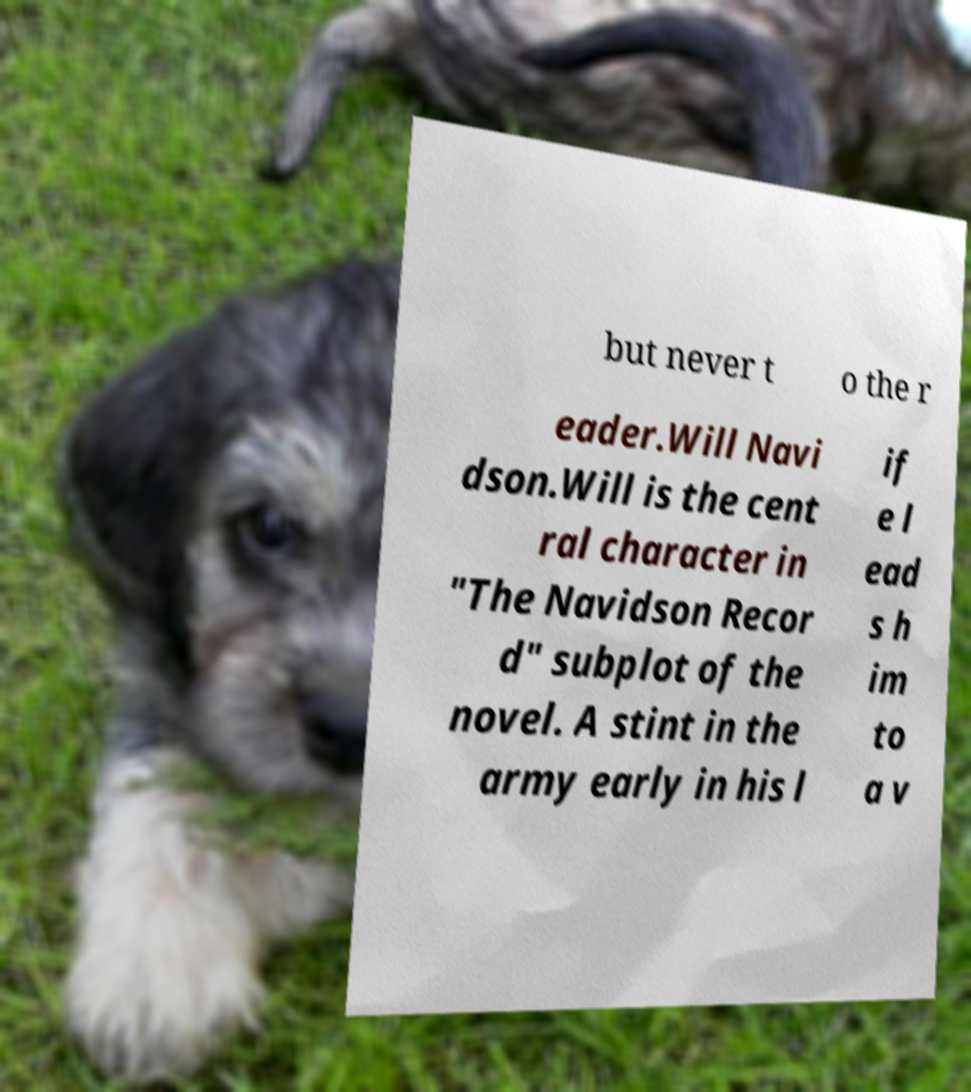What messages or text are displayed in this image? I need them in a readable, typed format. but never t o the r eader.Will Navi dson.Will is the cent ral character in "The Navidson Recor d" subplot of the novel. A stint in the army early in his l if e l ead s h im to a v 